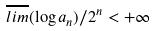Convert formula to latex. <formula><loc_0><loc_0><loc_500><loc_500>\overline { l i m } ( \log a _ { n } ) / 2 ^ { n } < + \infty</formula> 